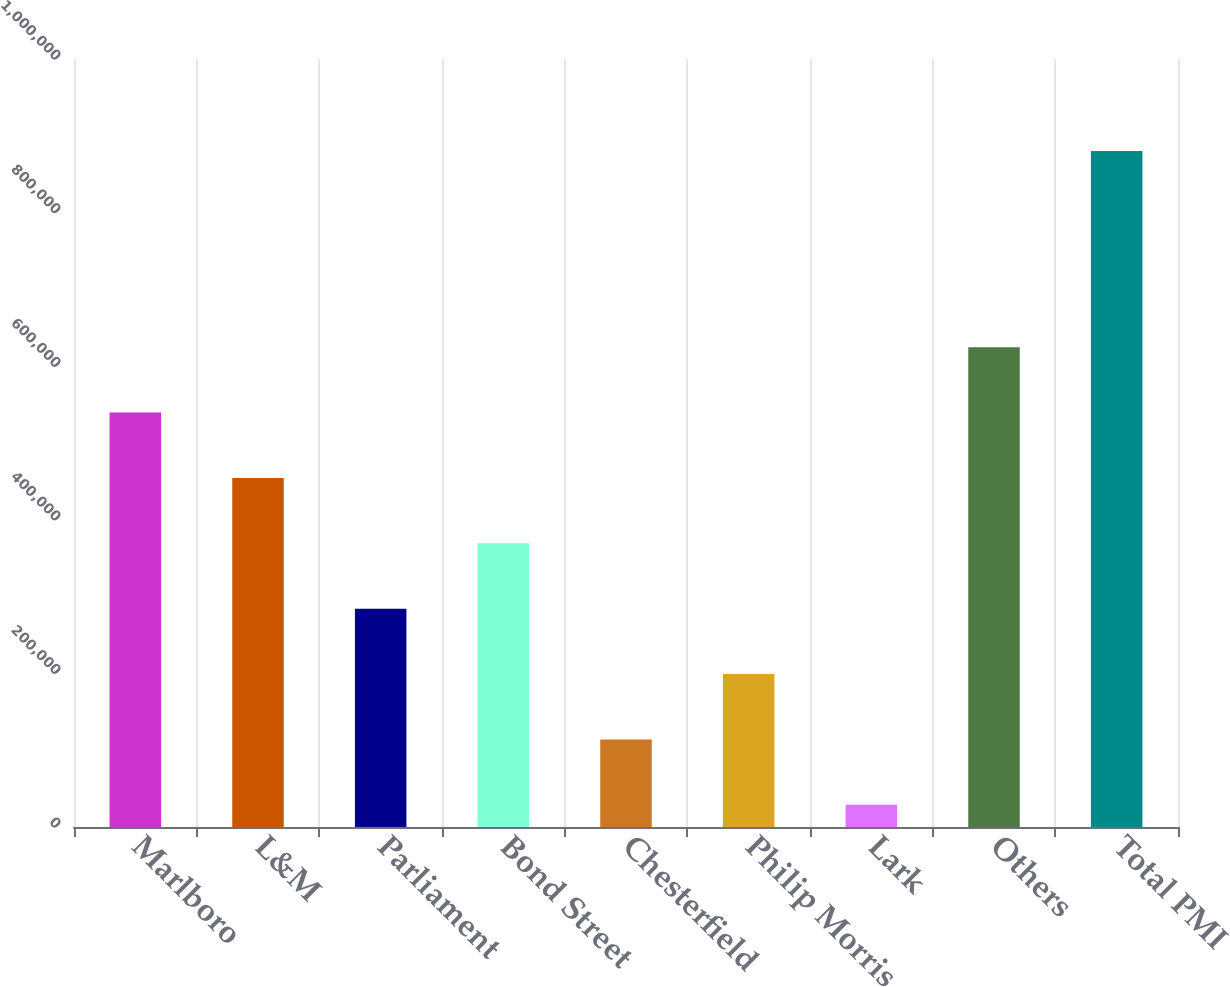Convert chart. <chart><loc_0><loc_0><loc_500><loc_500><bar_chart><fcel>Marlboro<fcel>L&M<fcel>Parliament<fcel>Bond Street<fcel>Chesterfield<fcel>Philip Morris<fcel>Lark<fcel>Others<fcel>Total PMI<nl><fcel>539638<fcel>454506<fcel>284240<fcel>369373<fcel>113975<fcel>199107<fcel>28842<fcel>624771<fcel>880169<nl></chart> 